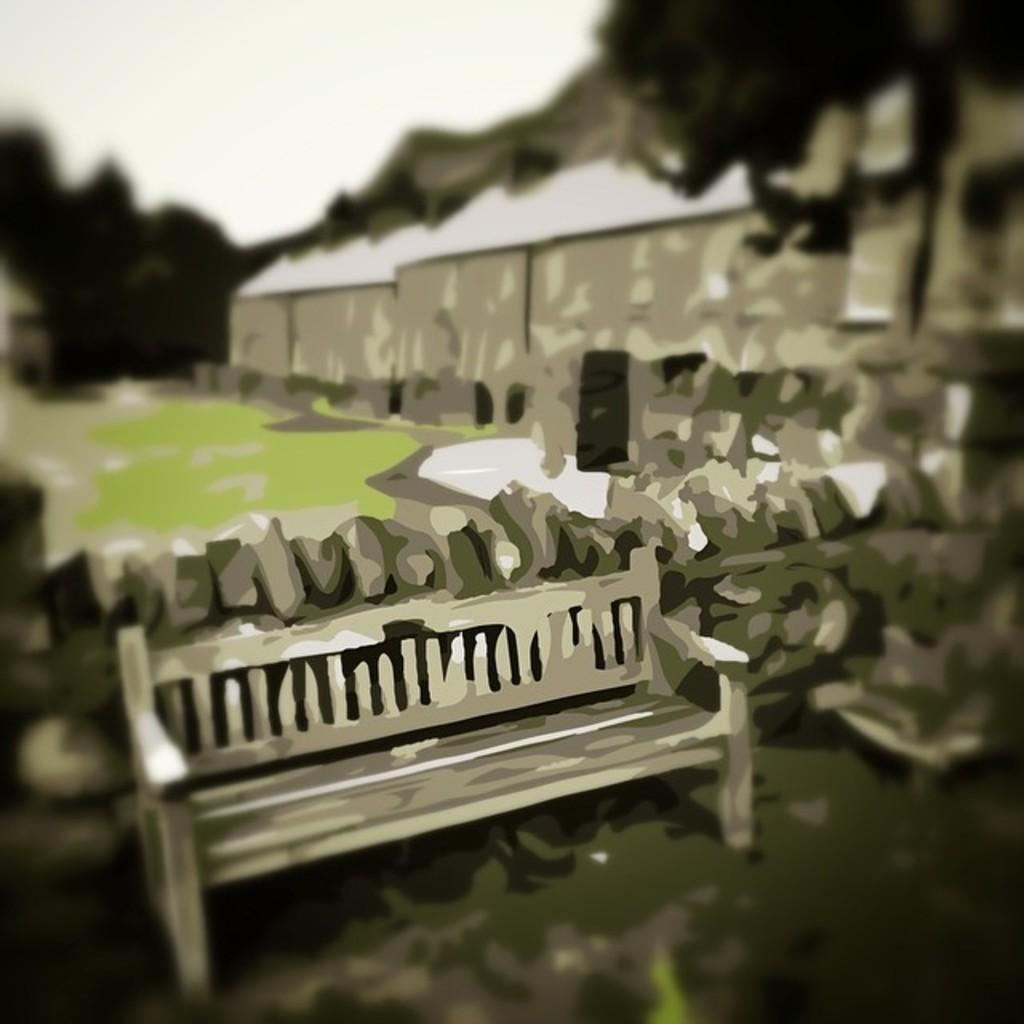What type of image is being described? The image appears to be animated. What type of furniture is present in the image? There is a wooden bench in the image. What is the background of the image made up of? There is a wall, grass, and trees in the image. What type of structures can be seen in the image? There are houses in the image. What type of fang can be seen in the image? There is no fang present in the image. What book is the character reading in the image? There is no character reading a book in the image, as it is an animated scene without any characters. 